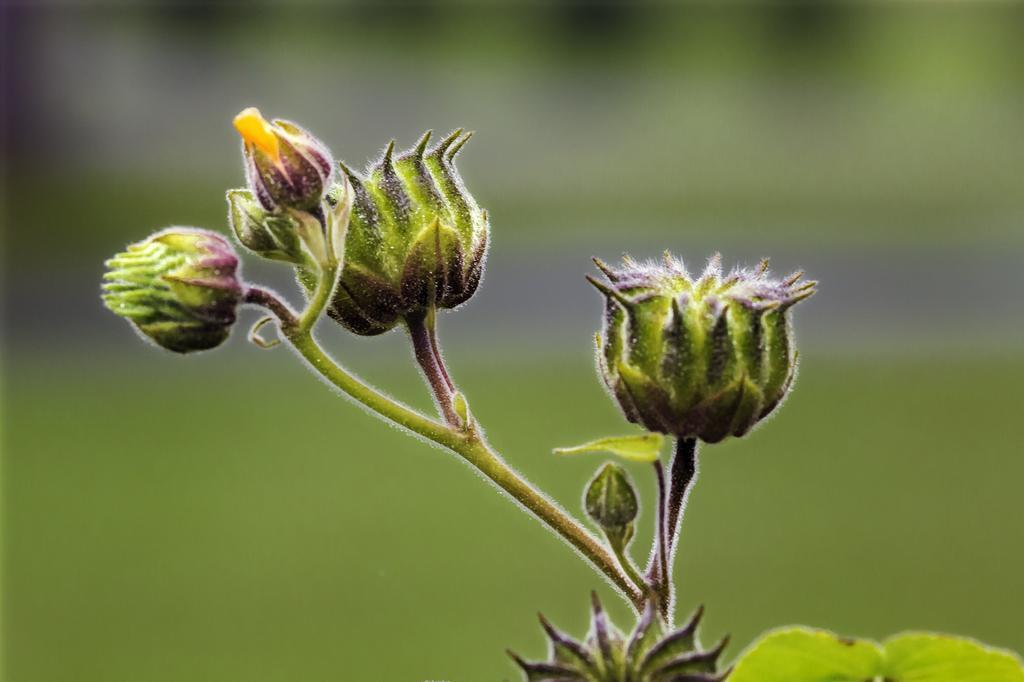How would you summarize this image in a sentence or two? In this image we can see a plant with buds. In the background the image is blur. 